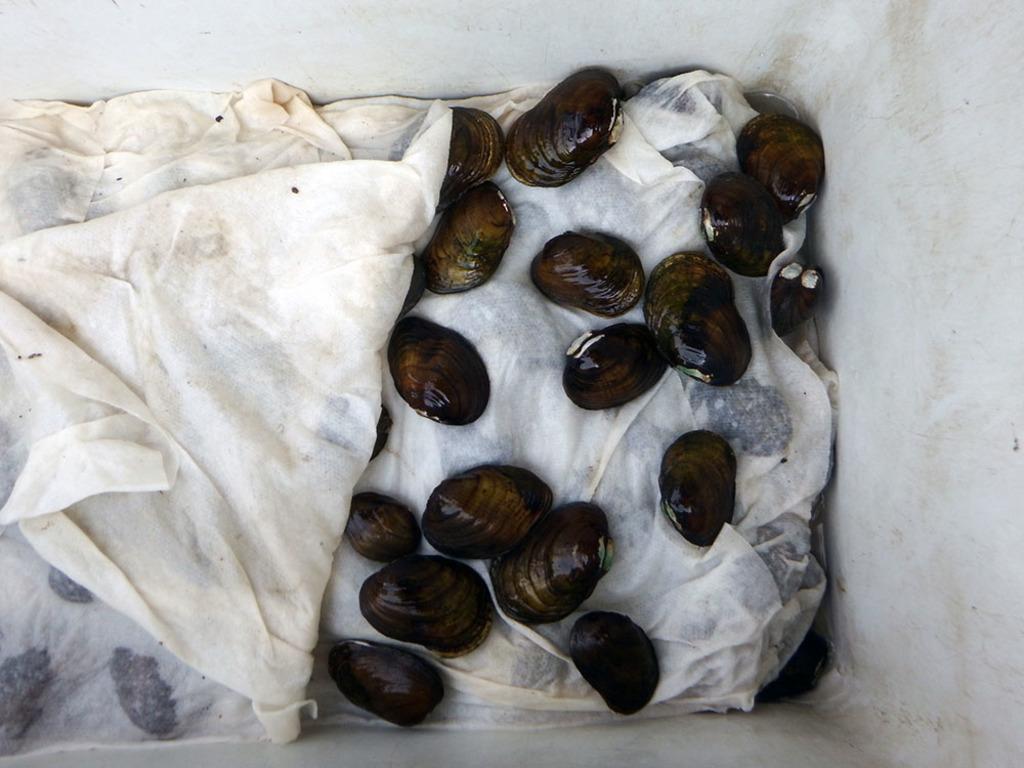What is the main object in the image? There is a box in the image. What is inside the box? There are oysters in the box. Is there anything else in the box besides the oysters? Yes, there is a cloth in the box. What type of hat can be seen on the ghost in the image? There is no hat or ghost present in the image; it only features a box with oysters and a cloth. 